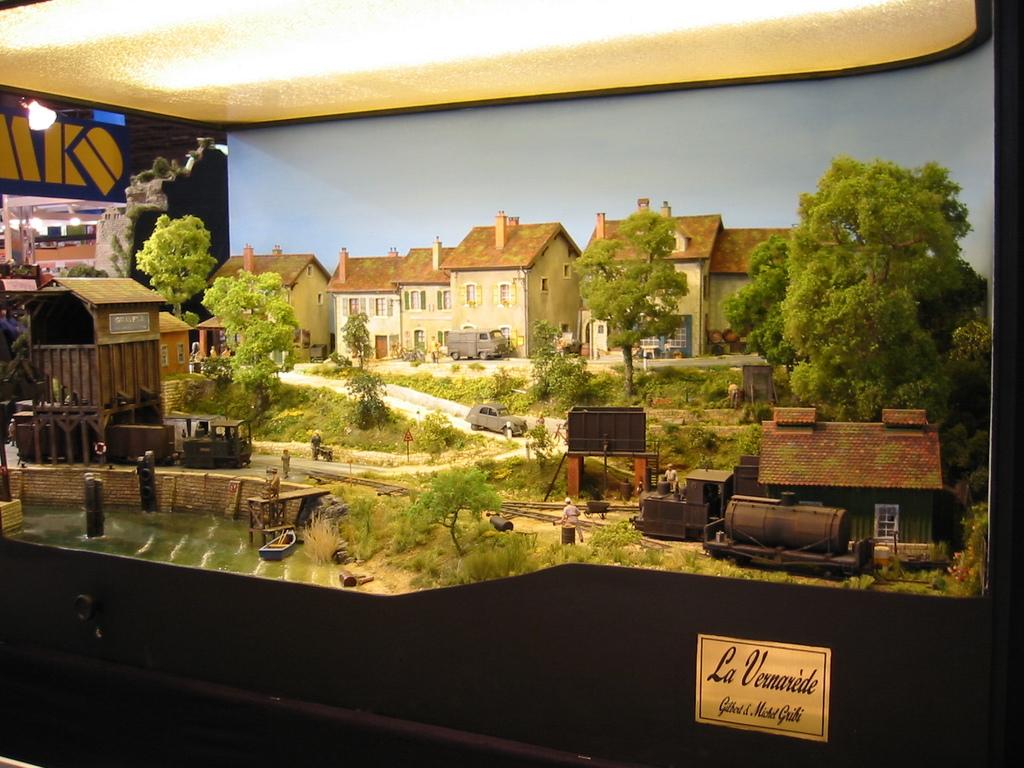What is the name of this scene?
Your answer should be very brief. La vernarede. 